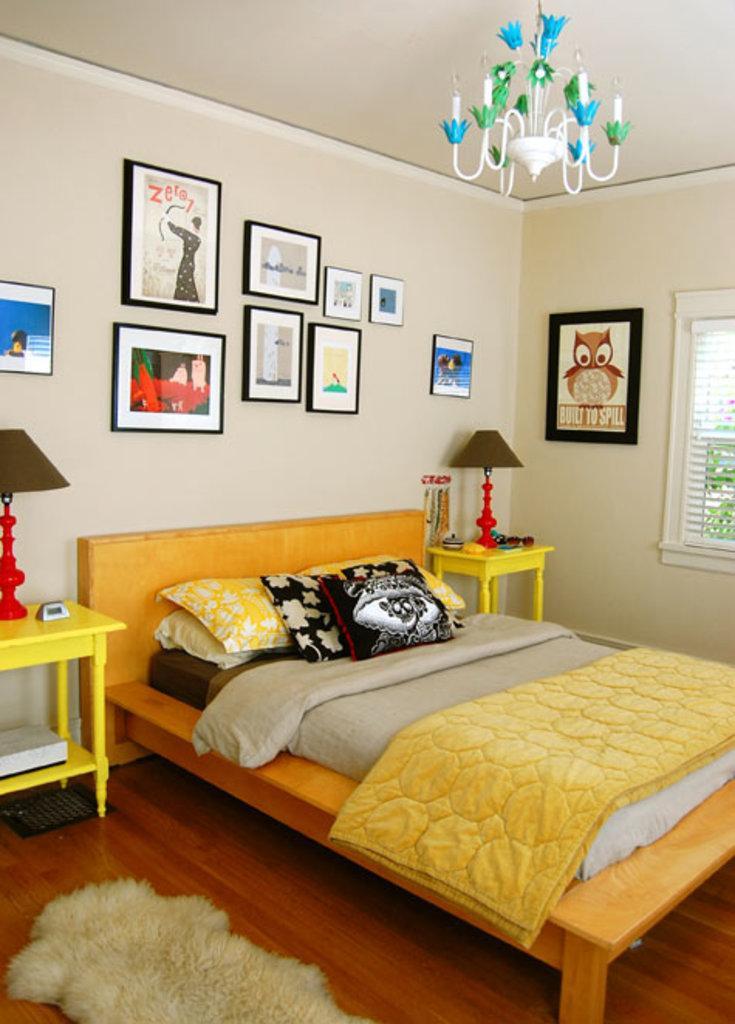How would you summarize this image in a sentence or two? In the center we can see bed,on bed there is a blanket,pillows. On the right we can see table,lamp,window,photo frame. And coming to background we can see photo frames and few objects. 